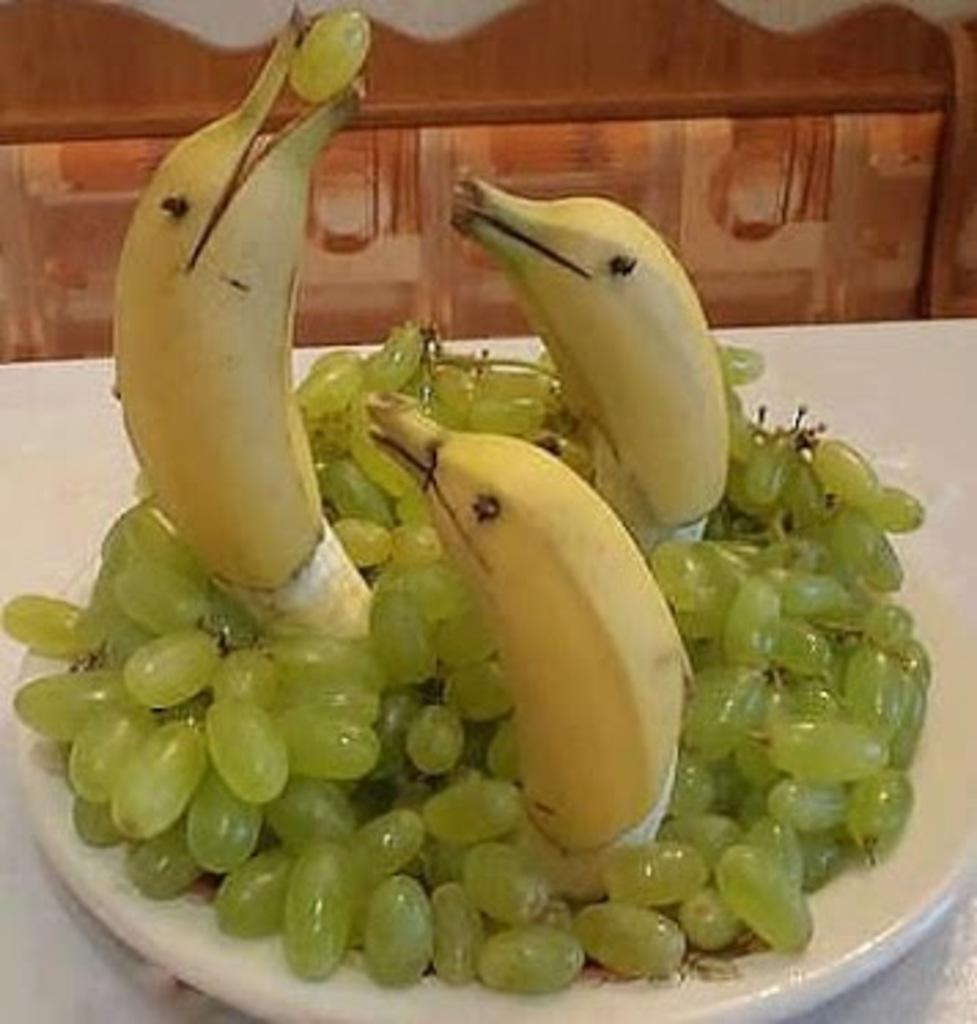What is on the plate in the image? There are grapes and 3 bananas on the plate in the image. What color is the plate? The plate is white. Can you describe anything in the background of the image? There is a brown color thing in the background of the image. How many cents are visible on the plate in the image? There are no cents visible on the plate in the image. What type of shoe can be seen in the background of the image? There is no shoe present in the image; only a brown color thing is visible in the background. 